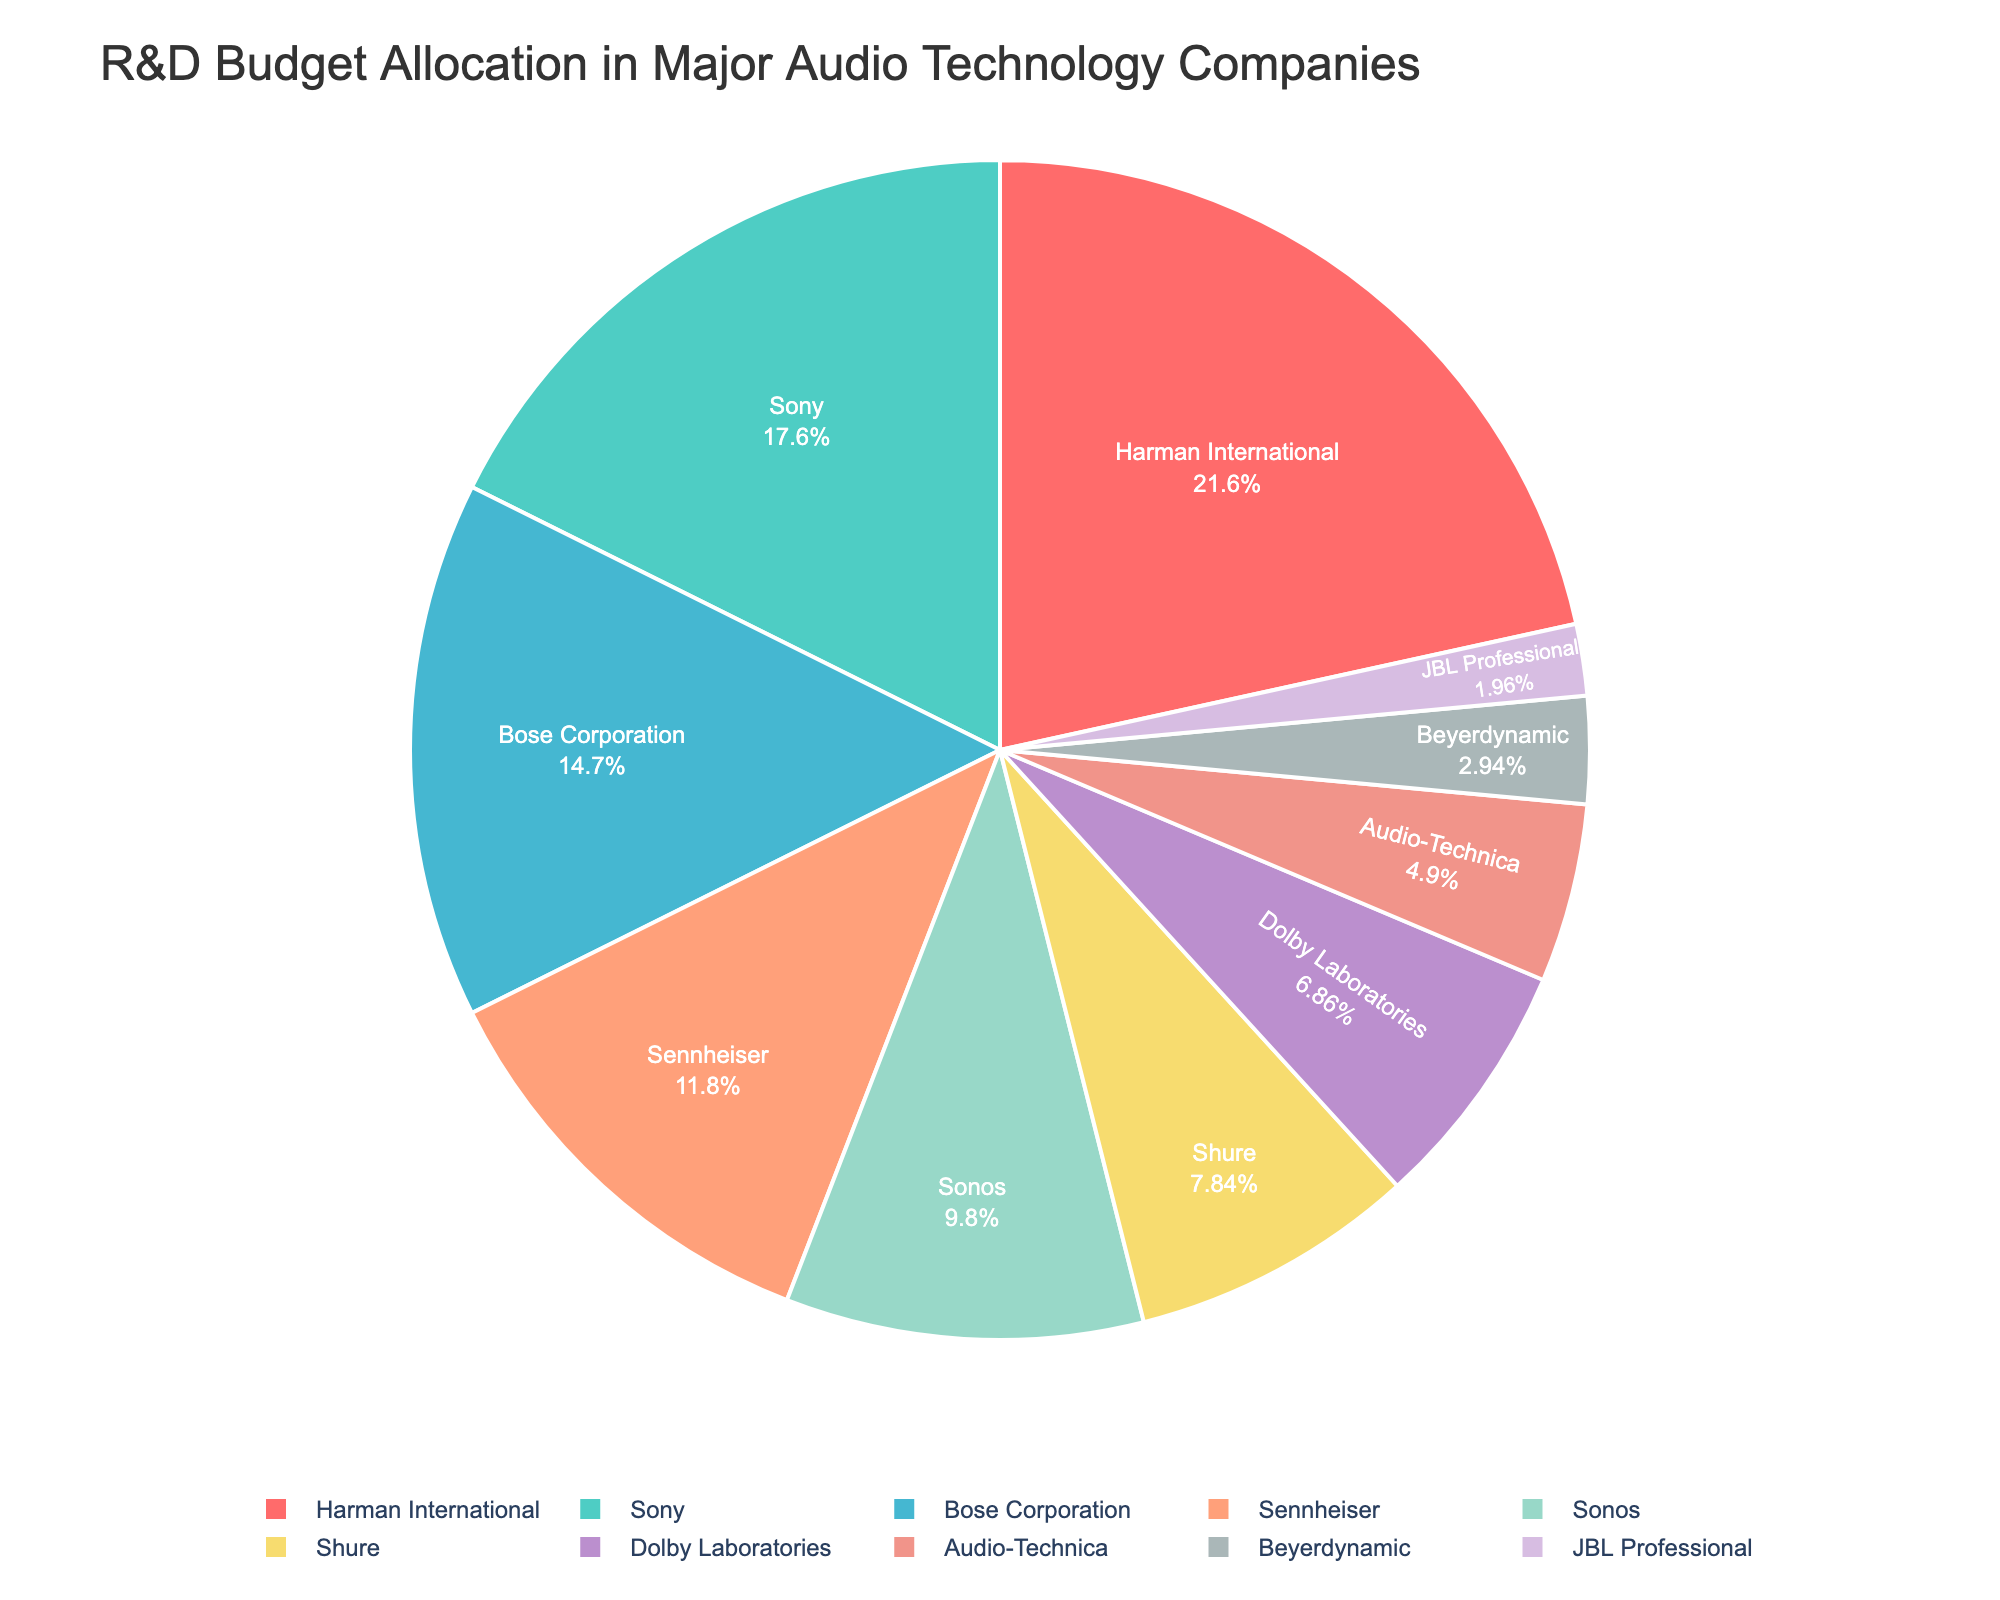What percentage of the R&D budget is allocated to Harman International? According to the pie chart, Harman International accounts for 22% of the total R&D budget.
Answer: 22% Which company has the smallest allocation, and what percentage is it? By observing the pie chart, JBL Professional has the smallest allocation, which is 2% of the total R&D budget.
Answer: JBL Professional, 2% How much greater is the R&D budget for Bose Corporation compared to Shure? Bose Corporation has 15% and Shure has 8%. The difference is calculated by subtracting Shure's percentage from Bose Corporation's percentage, which is 15% - 8% = 7%.
Answer: 7% If you combined the R&D budgets of Sony and Sennheiser, what would their total percentage be? Sony has 18% and Sennheiser has 12%. Adding these together gives 18% + 12% = 30%.
Answer: 30% Which companies have an R&D budget allocation of greater than 15%? The companies with more than 15% of the R&D budget are Harman International (22%) and Sony (18%).
Answer: Harman International, Sony What is the average R&D budget percentage for Sonos, Shure, and Dolby Laboratories? The percentages for Sonos, Shure, and Dolby Laboratories are 10%, 8%, and 7%, respectively. The average is calculated as (10% + 8% + 7%) / 3 = 25% / 3 ≈ 8.33%.
Answer: 8.33% What percentage of the R&D budget does Sony have more than Audio-Technica? Sony has 18% and Audio-Technica has 5%. The difference is 18% - 5% = 13%.
Answer: 13% Which companies fall within the middle range of R&D budget allocation, based on the visual impression of the pie chart? By looking at the pie chart, companies with mid-range allocations (around 7-12%) include Sennheiser (12%), Sonos (10%), and Shure (8%), with Dolby Laboratories (7%) also on the lower end of this range.
Answer: Sennheiser, Sonos, Shure, Dolby Laboratories Among the companies with the smallest allocations, which one assigns a relatively higher percentage to R&D compared to the smallest one (JBL Professional at 2%)? The companies with small allocations are Beyerdynamic (3%) and Audio-Technica (5%)—both of these assign a higher percentage compared to JBL Professional's 2%. Beyerdynamic would be the one with the higher percentage immediately next to JBL Professional.
Answer: Beyerdynamic 